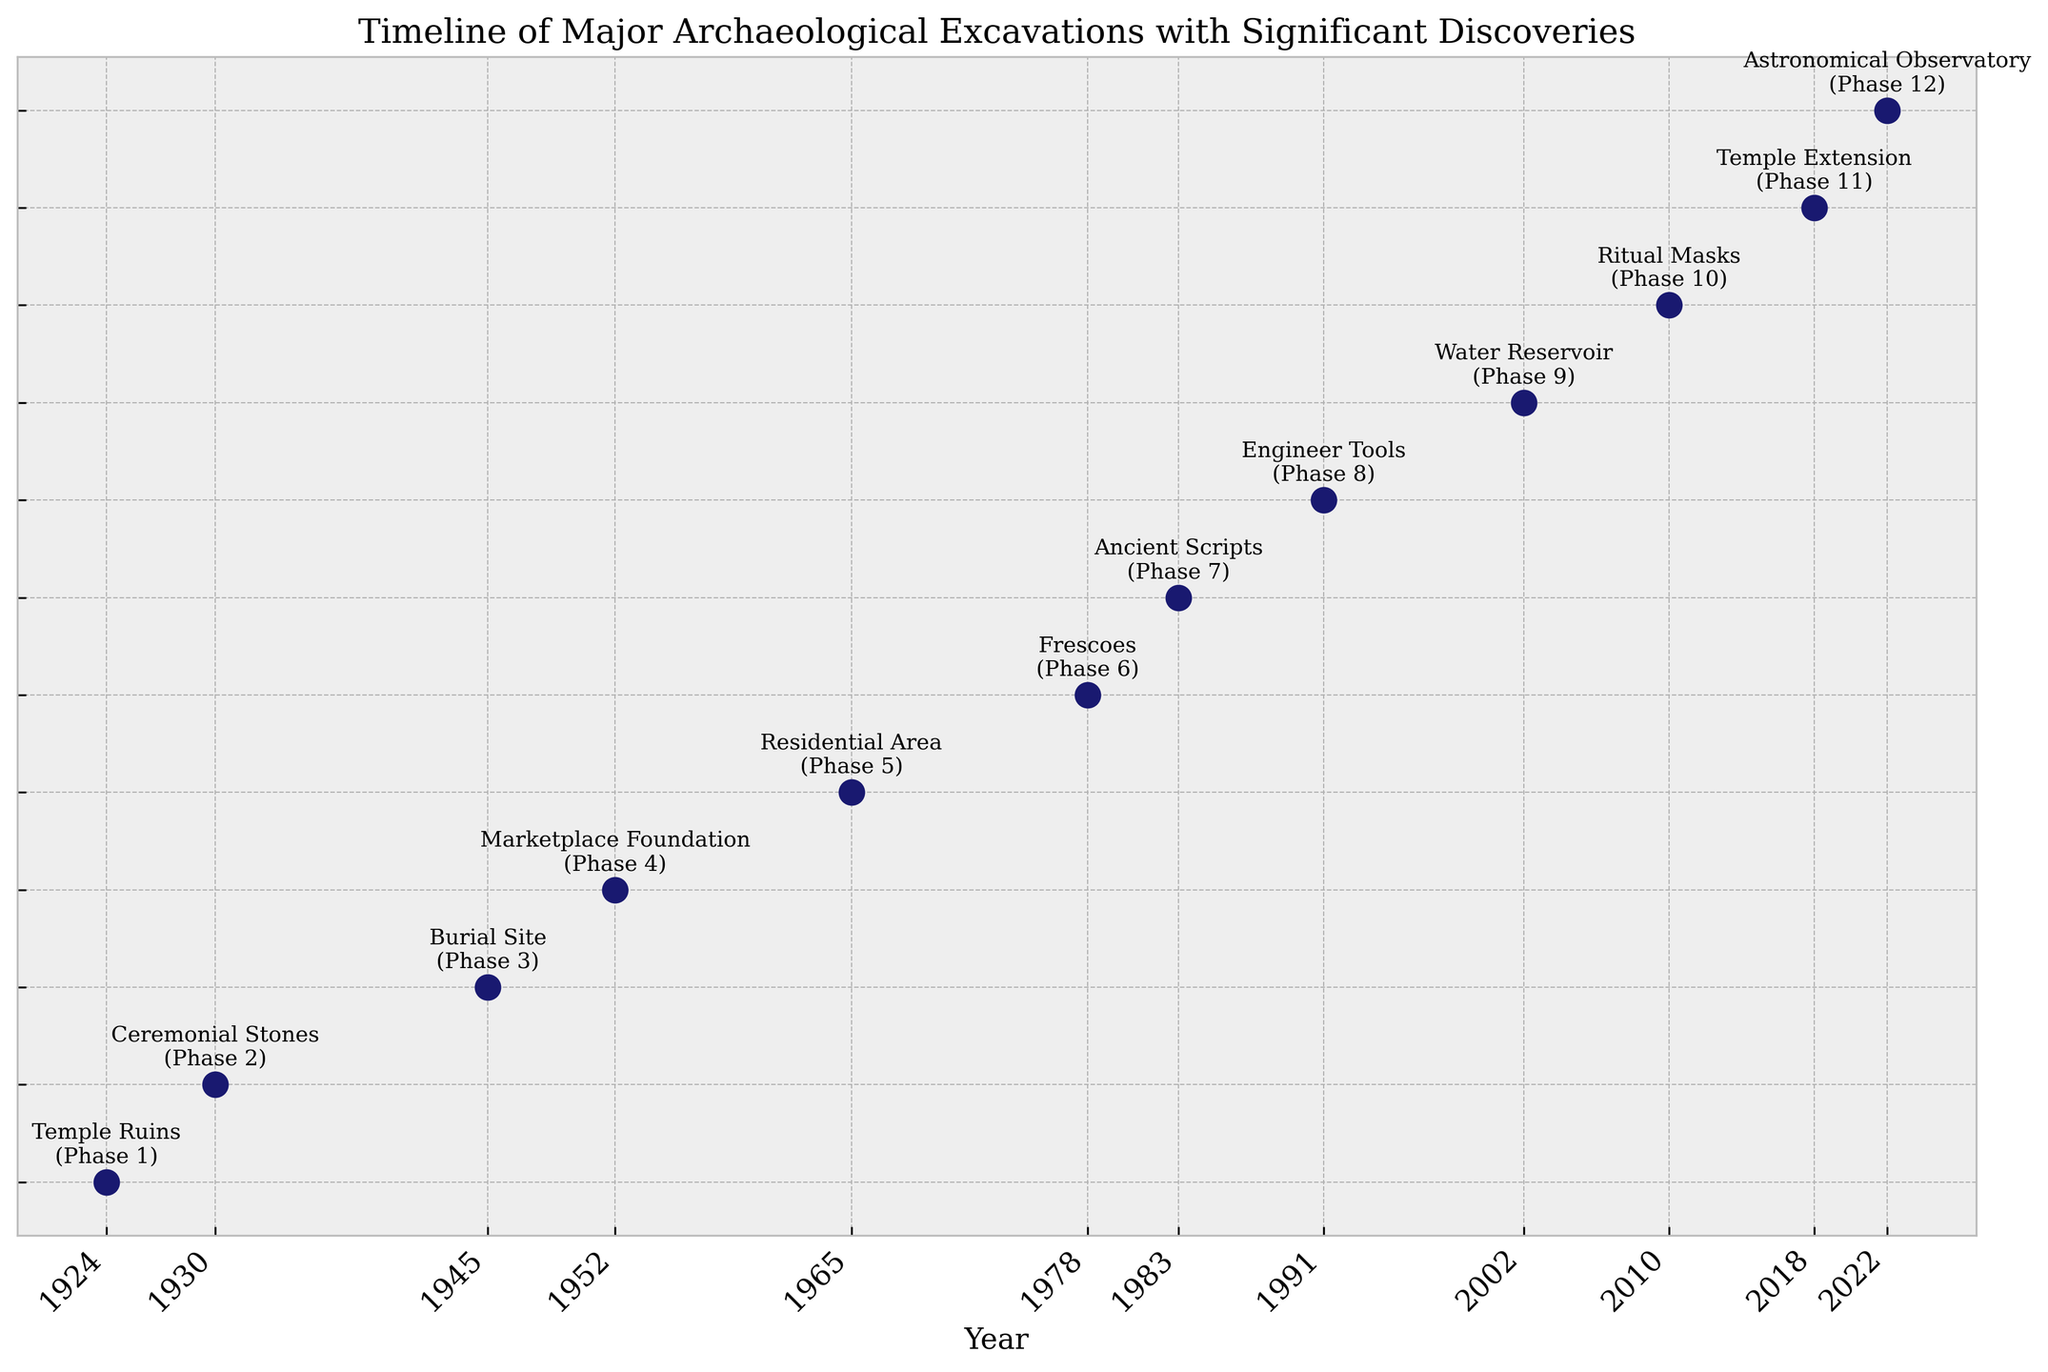How many years passed between the Temple Ruins discovery and the Astronomical Observatory discovery? We need to subtract the year of the Temple Ruins discovery (1924) from the year of the Astronomical Observatory discovery (2022). 2022 - 1924 = 98 years.
Answer: 98 Which phase had a significant discovery made earliest in the 2000s? From the figure, the earliest significant discovery in the 2000s was in phase 9 (Water Reservoir) which took place in 2002.
Answer: Phase 9 What is the median year of the excavation phases listed on the plot? To find the median, list the years in ascending order and find the middle value. The years are: 1924, 1930, 1945, 1952, 1965, 1978, 1983, 1991, 2002, 2010, 2018, 2022. The median value, as the list has 12 items, will be the average of the 6th and 7th values. (1978 + 1983) / 2 = 1980.5.
Answer: 1980.5 Between which two phases did the largest gap in years occur? The largest gap in years occurred between phases 8 (1991) and 9 (2002). Calculate the difference: 2002 - 1991 = 11 years.
Answer: Between Phases 8 and 9 How does the discovery of Ritual Masks compare to the discovery of Temple Extension in terms of time? We need to compare the years when these two discoveries were made. Ritual Masks were discovered in 2010, and Temple Extension was discovered in 2018. 2018 - 2010 = 8 years later.
Answer: 8 years Which phase had the discovery of Frescoes and in what year did it occur? The discovery of Frescoes occurred in phase 6, and it took place in the year 1978.
Answer: Phase 6, 1978 How many significant discoveries were made after the year 2000? From the figure, the discoveries made after the year 2000 are Water Reservoir (2002), Ritual Masks (2010), Temple Extension (2018), and Astronomical Observatory (2022). Counting these gives us 4 discoveries.
Answer: 4 Compare the number of years between the discovery of Marketplace Foundation and Residential Area to the number of years between Residential Area and Frescoes. Marketplace Foundation was discovered in 1952, Residential Area in 1965, and Frescoes in 1978. For the first comparison: 1965 - 1952 = 13 years. For the second comparison: 1978 - 1965 = 13 years. Both intervals are equal.
Answer: Both intervals are 13 years What significant discovery was made in Phase 4? From the figure, Phase 4 corresponds to the discovery of the Marketplace Foundation.
Answer: Marketplace Foundation What is unique about the discovery made in Phase 7? The discovery made in Phase 7 was of Ancient Scripts, which are unique because they contain undeciphered ancient scripts.
Answer: Ancient Scripts 